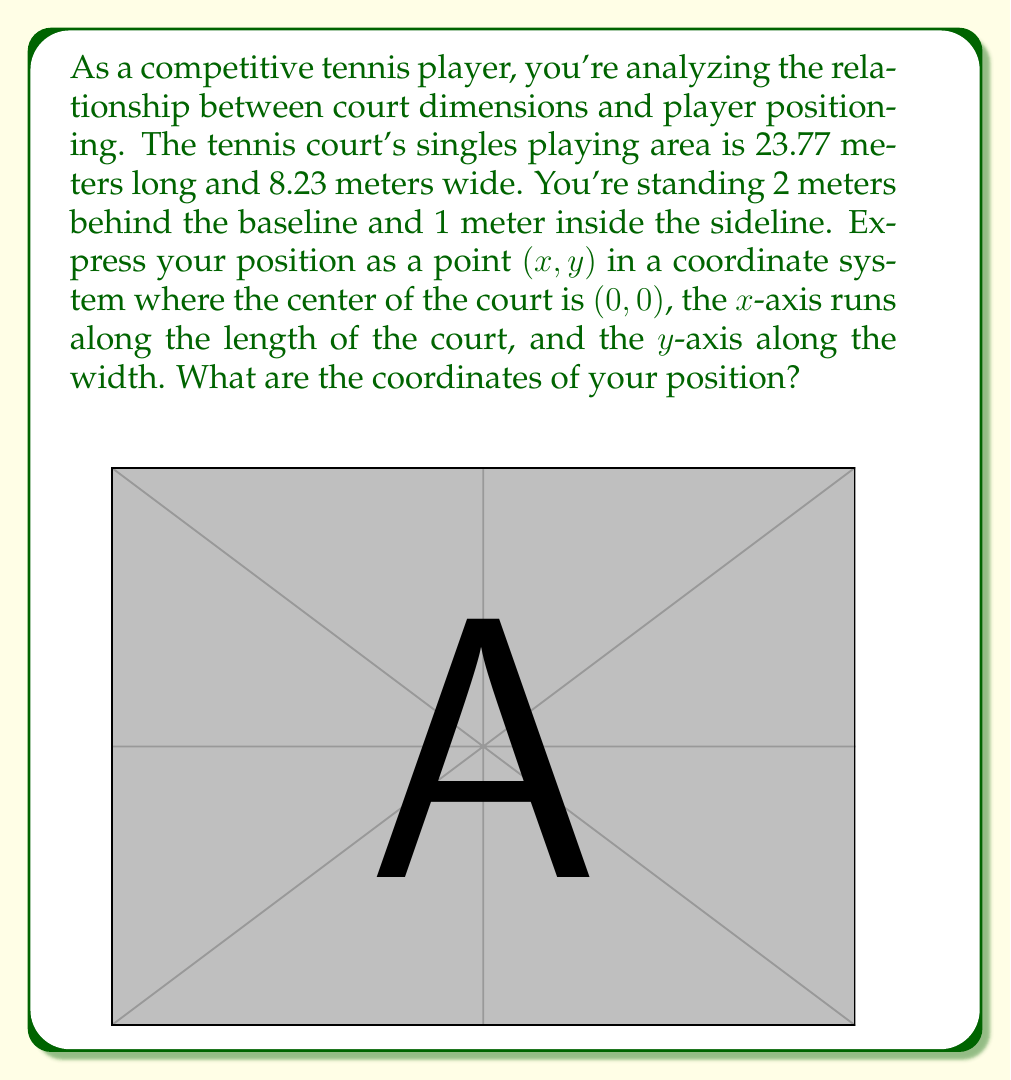Solve this math problem. Let's approach this step-by-step:

1) First, we need to understand the coordinate system:
   - The center of the court is (0, 0)
   - The x-axis runs along the length of the court
   - The y-axis runs along the width of the court

2) Let's calculate the x-coordinate:
   - The court is 23.77 meters long, so half of that is 23.77/2 = 11.885 meters
   - You're standing 2 meters behind the baseline, so:
     $x = 11.885 + 2 = 13.885$ meters

3) Now for the y-coordinate:
   - The court is 8.23 meters wide, so half of that is 8.23/2 = 4.115 meters
   - You're standing 1 meter inside the sideline, so:
     $y = 4.115 - 1 = 3.115$ meters

4) However, we need to consider which quadrant you're in:
   - You're on the positive x-axis (to the right of center)
   - You're on the negative y-axis (below center, assuming the positive y-axis points upwards)

5) Therefore, the final coordinates are:
   $(13.885, -3.115)$

This point represents your position relative to the center of the court, taking into account the court dimensions and your specific position behind the baseline and inside the sideline.
Answer: $(13.885, -3.115)$ 